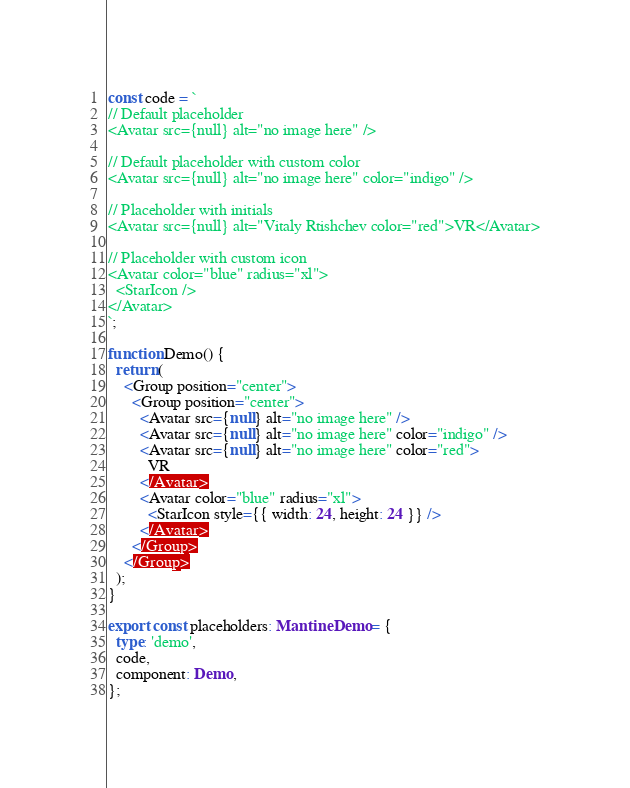Convert code to text. <code><loc_0><loc_0><loc_500><loc_500><_TypeScript_>
const code = `
// Default placeholder
<Avatar src={null} alt="no image here" />

// Default placeholder with custom color
<Avatar src={null} alt="no image here" color="indigo" />

// Placeholder with initials
<Avatar src={null} alt="Vitaly Rtishchev color="red">VR</Avatar>

// Placeholder with custom icon
<Avatar color="blue" radius="xl">
  <StarIcon />
</Avatar>
`;

function Demo() {
  return (
    <Group position="center">
      <Group position="center">
        <Avatar src={null} alt="no image here" />
        <Avatar src={null} alt="no image here" color="indigo" />
        <Avatar src={null} alt="no image here" color="red">
          VR
        </Avatar>
        <Avatar color="blue" radius="xl">
          <StarIcon style={{ width: 24, height: 24 }} />
        </Avatar>
      </Group>
    </Group>
  );
}

export const placeholders: MantineDemo = {
  type: 'demo',
  code,
  component: Demo,
};
</code> 